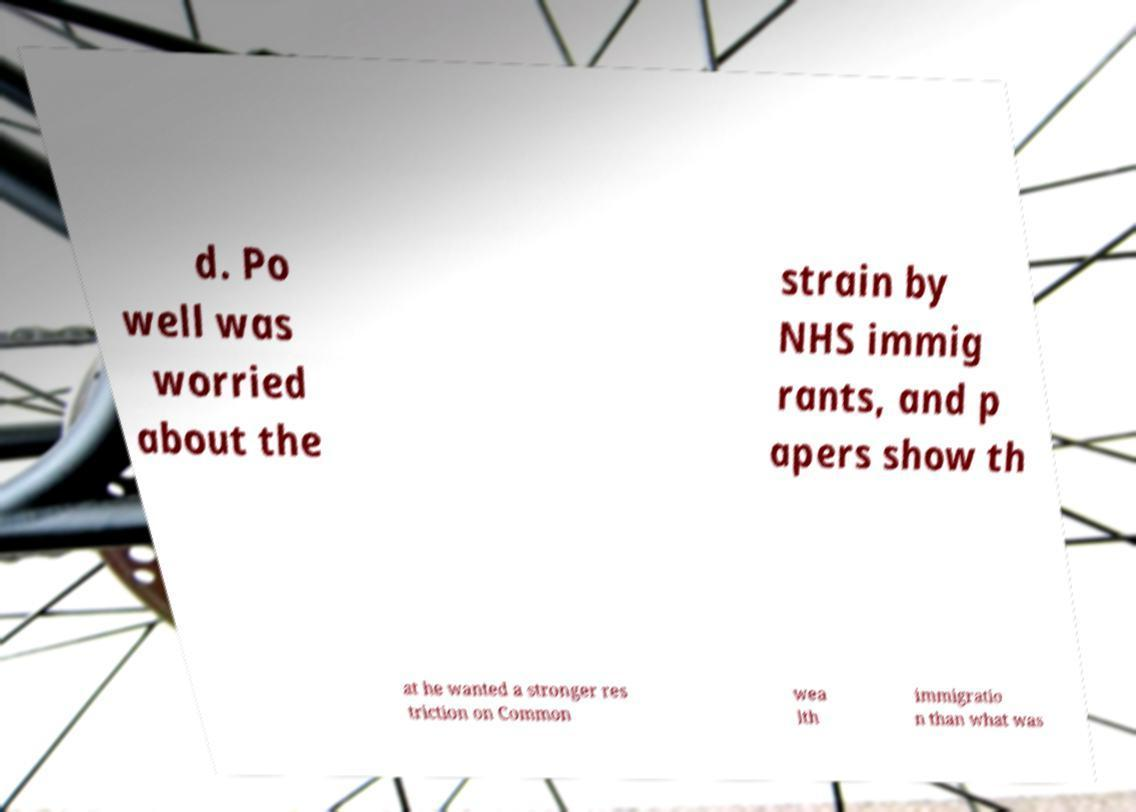Could you extract and type out the text from this image? d. Po well was worried about the strain by NHS immig rants, and p apers show th at he wanted a stronger res triction on Common wea lth immigratio n than what was 